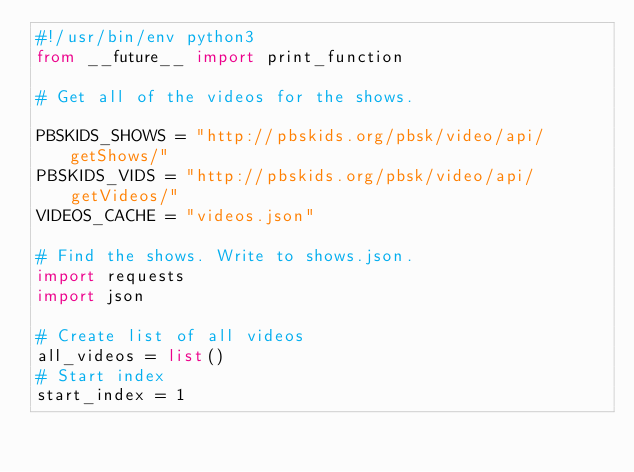Convert code to text. <code><loc_0><loc_0><loc_500><loc_500><_Python_>#!/usr/bin/env python3
from __future__ import print_function

# Get all of the videos for the shows.

PBSKIDS_SHOWS = "http://pbskids.org/pbsk/video/api/getShows/"
PBSKIDS_VIDS = "http://pbskids.org/pbsk/video/api/getVideos/"
VIDEOS_CACHE = "videos.json"

# Find the shows. Write to shows.json.
import requests
import json

# Create list of all videos
all_videos = list()
# Start index
start_index = 1</code> 